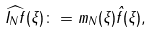<formula> <loc_0><loc_0><loc_500><loc_500>\widehat { I _ { N } f } ( \xi ) \colon = m _ { N } ( \xi ) \hat { f } ( \xi ) ,</formula> 